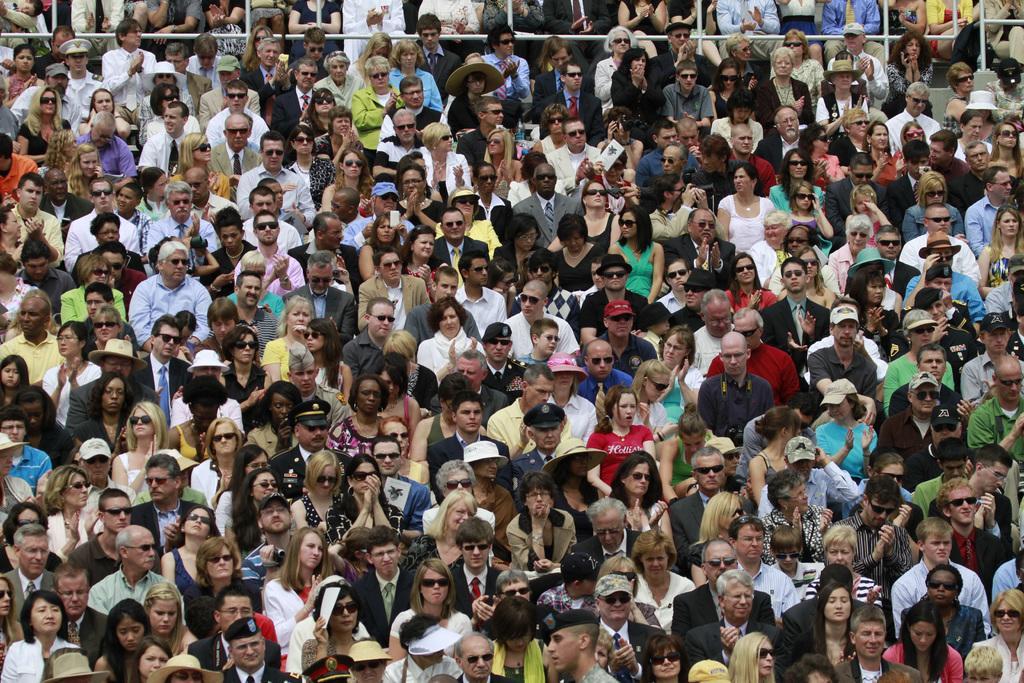Could you give a brief overview of what you see in this image? In this image we can see a group of people. 